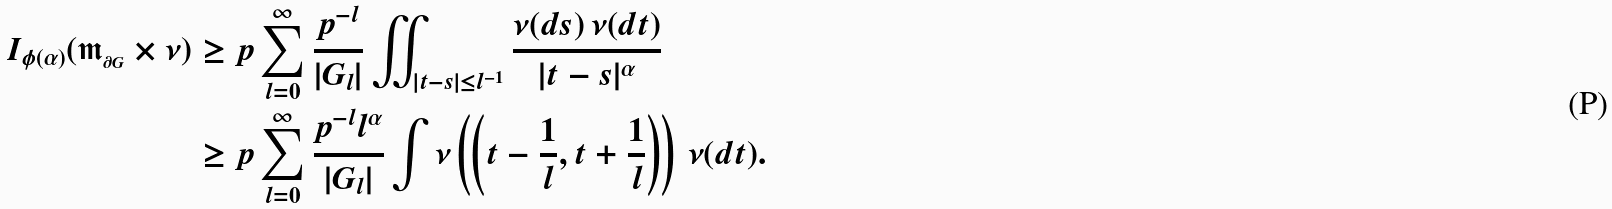Convert formula to latex. <formula><loc_0><loc_0><loc_500><loc_500>I _ { \phi ( \alpha ) } ( \mathfrak { m } _ { _ { \partial G } } \times \nu ) & \geq p \sum _ { l = 0 } ^ { \infty } \frac { p ^ { - l } } { | G _ { l } | } \iint _ { | t - s | \leq l ^ { - 1 } } \frac { \nu ( d s ) \, \nu ( d t ) } { | t - s | ^ { \alpha } } \\ & \geq p \sum _ { l = 0 } ^ { \infty } \frac { p ^ { - l } l ^ { \alpha } } { | G _ { l } | } \int \nu \left ( \left ( t - \frac { 1 } { l } , t + \frac { 1 } { l } \right ) \right ) \, \nu ( d t ) .</formula> 